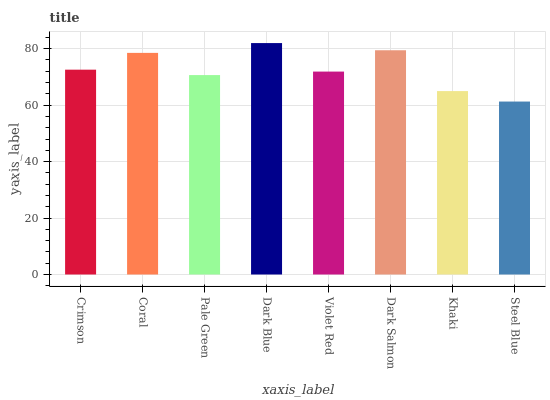Is Steel Blue the minimum?
Answer yes or no. Yes. Is Dark Blue the maximum?
Answer yes or no. Yes. Is Coral the minimum?
Answer yes or no. No. Is Coral the maximum?
Answer yes or no. No. Is Coral greater than Crimson?
Answer yes or no. Yes. Is Crimson less than Coral?
Answer yes or no. Yes. Is Crimson greater than Coral?
Answer yes or no. No. Is Coral less than Crimson?
Answer yes or no. No. Is Crimson the high median?
Answer yes or no. Yes. Is Violet Red the low median?
Answer yes or no. Yes. Is Dark Blue the high median?
Answer yes or no. No. Is Dark Salmon the low median?
Answer yes or no. No. 